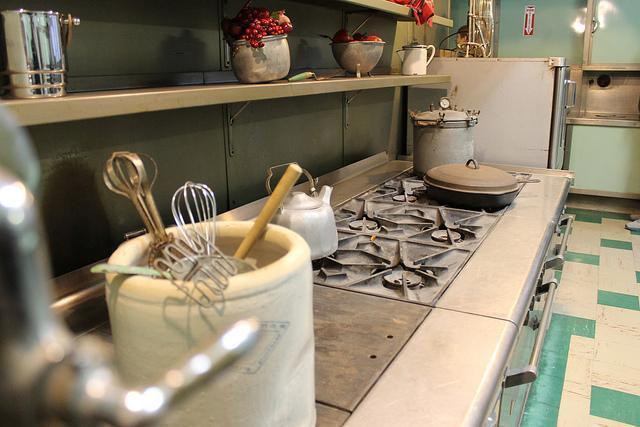What could the pot with the round white gauge on top be used for?
Select the accurate answer and provide justification: `Answer: choice
Rationale: srationale.`
Options: Baking bread, canning fruit, making candy, peeling carrots. Answer: canning fruit.
Rationale: The pot is for fruit. 